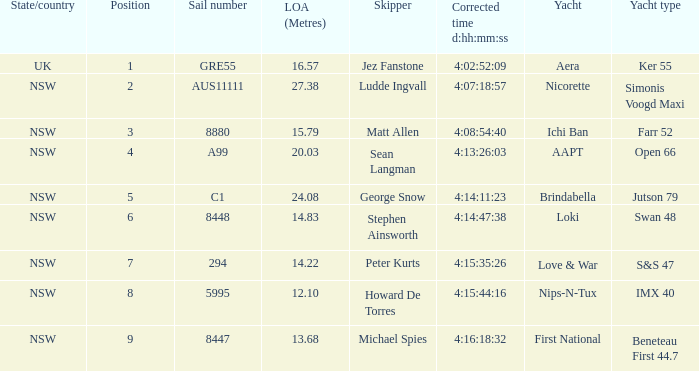Parse the table in full. {'header': ['State/country', 'Position', 'Sail number', 'LOA (Metres)', 'Skipper', 'Corrected time d:hh:mm:ss', 'Yacht', 'Yacht type'], 'rows': [['UK', '1', 'GRE55', '16.57', 'Jez Fanstone', '4:02:52:09', 'Aera', 'Ker 55'], ['NSW', '2', 'AUS11111', '27.38', 'Ludde Ingvall', '4:07:18:57', 'Nicorette', 'Simonis Voogd Maxi'], ['NSW', '3', '8880', '15.79', 'Matt Allen', '4:08:54:40', 'Ichi Ban', 'Farr 52'], ['NSW', '4', 'A99', '20.03', 'Sean Langman', '4:13:26:03', 'AAPT', 'Open 66'], ['NSW', '5', 'C1', '24.08', 'George Snow', '4:14:11:23', 'Brindabella', 'Jutson 79'], ['NSW', '6', '8448', '14.83', 'Stephen Ainsworth', '4:14:47:38', 'Loki', 'Swan 48'], ['NSW', '7', '294', '14.22', 'Peter Kurts', '4:15:35:26', 'Love & War', 'S&S 47'], ['NSW', '8', '5995', '12.10', 'Howard De Torres', '4:15:44:16', 'Nips-N-Tux', 'IMX 40'], ['NSW', '9', '8447', '13.68', 'Michael Spies', '4:16:18:32', 'First National', 'Beneteau First 44.7']]} What is the total length of sail for the boat with an accurate time of 4:15:35:26? 14.22. 